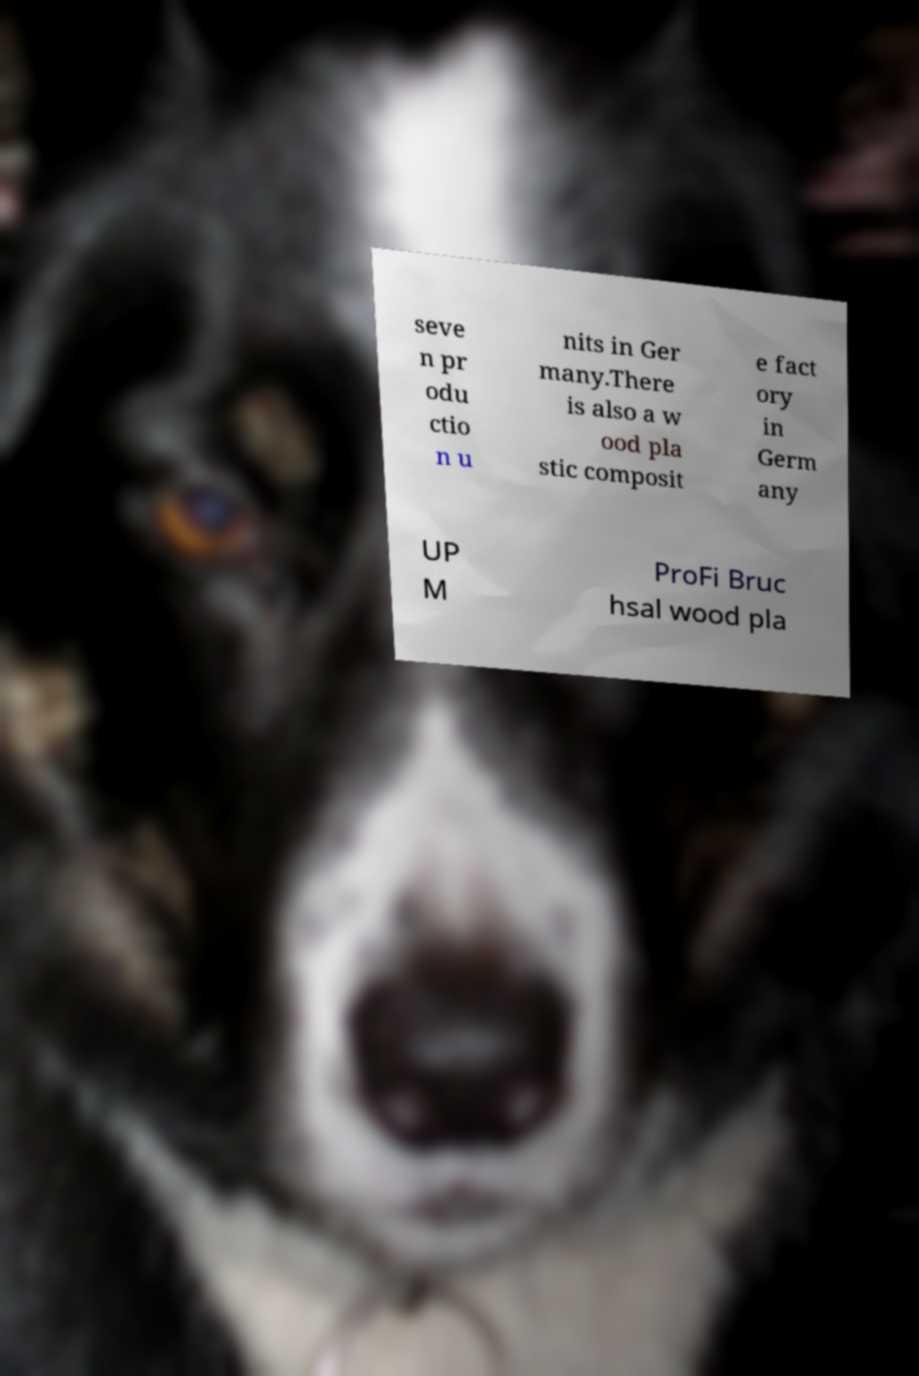For documentation purposes, I need the text within this image transcribed. Could you provide that? seve n pr odu ctio n u nits in Ger many.There is also a w ood pla stic composit e fact ory in Germ any UP M ProFi Bruc hsal wood pla 